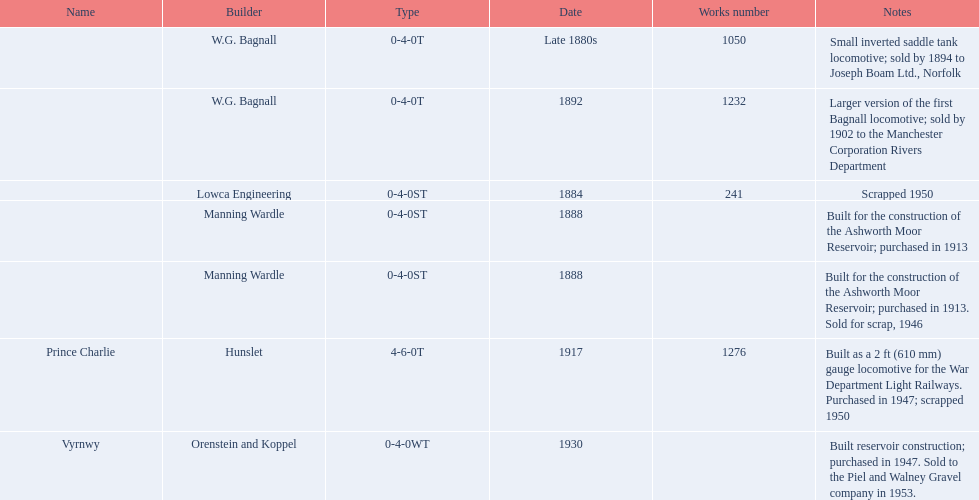What is the count of locomotives that were scrapped? 3. 